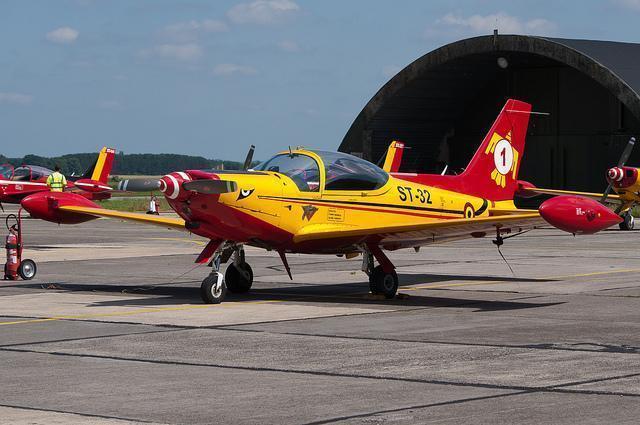What is the purpose of the black structure?
From the following set of four choices, select the accurate answer to respond to the question.
Options: House planes, store tools, restaurant, police station. House planes. 